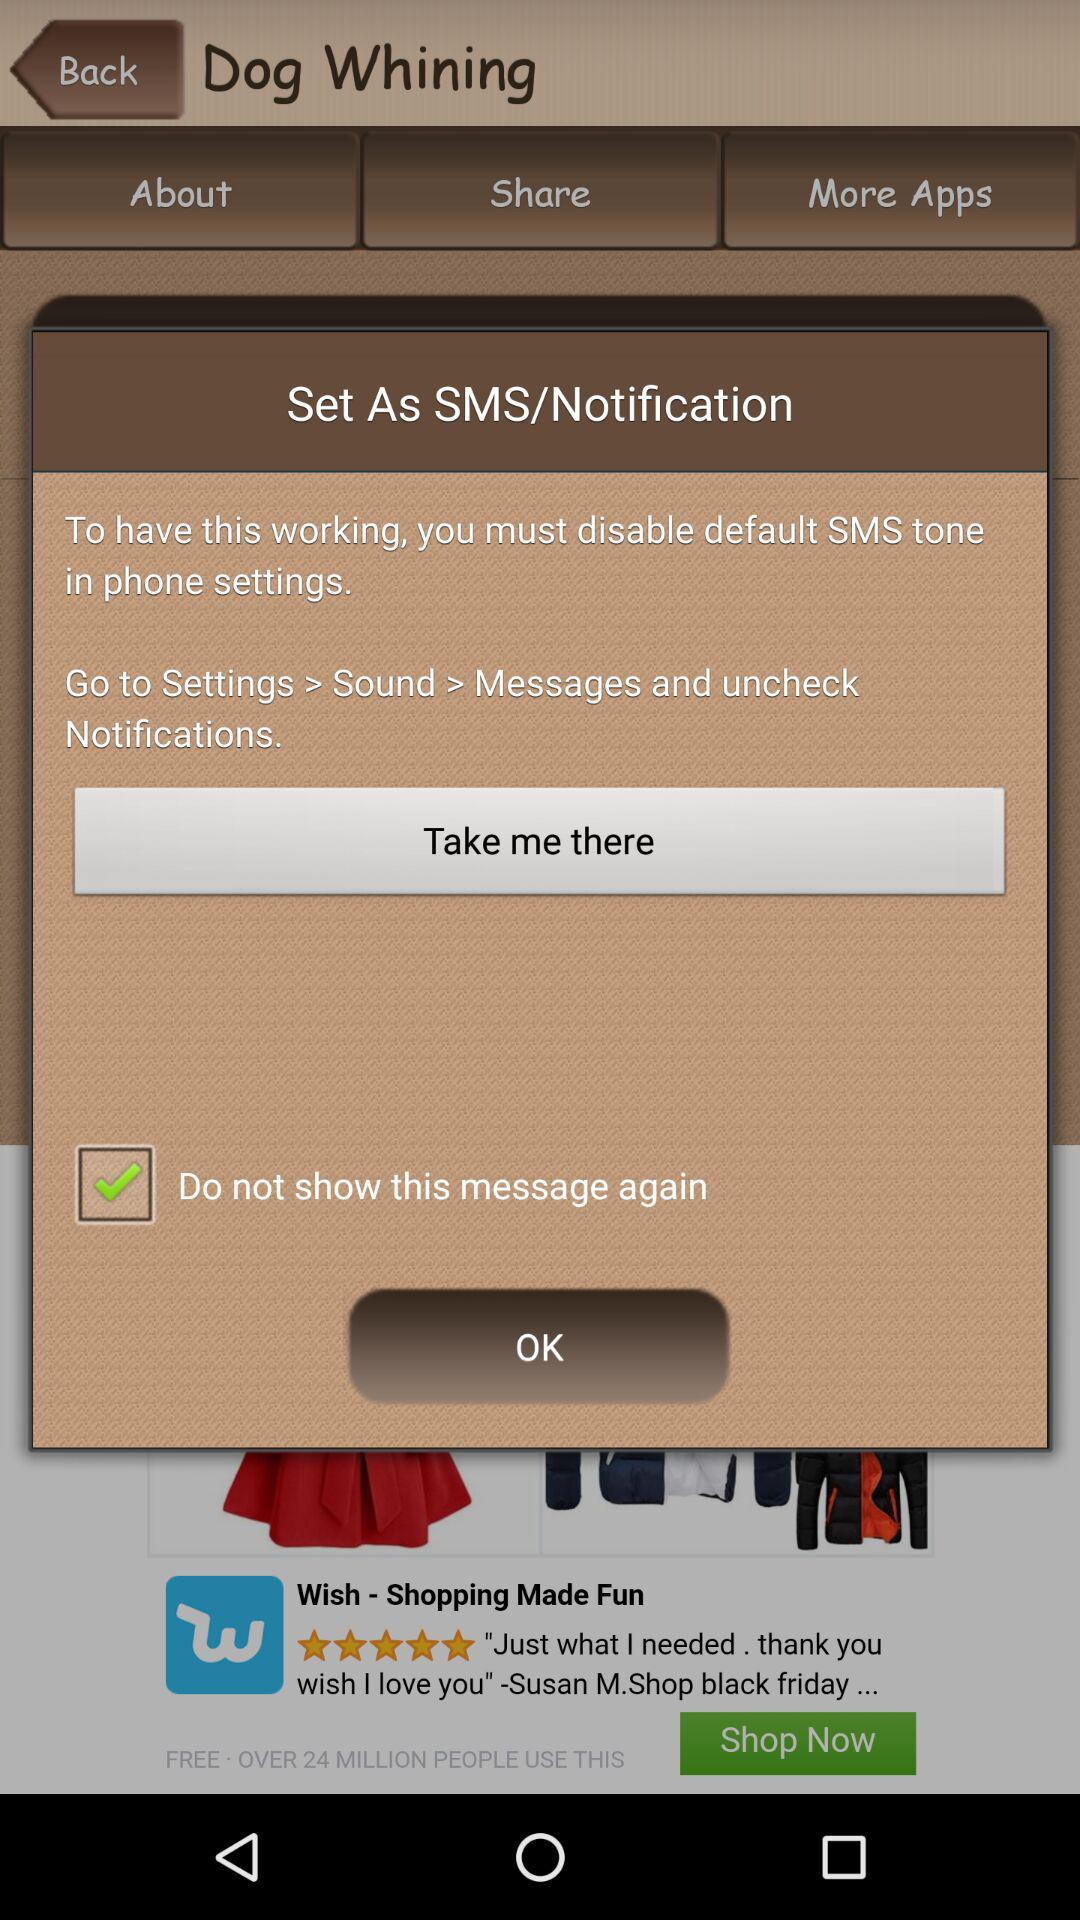What is the status of do not show this message again? The status is on. 